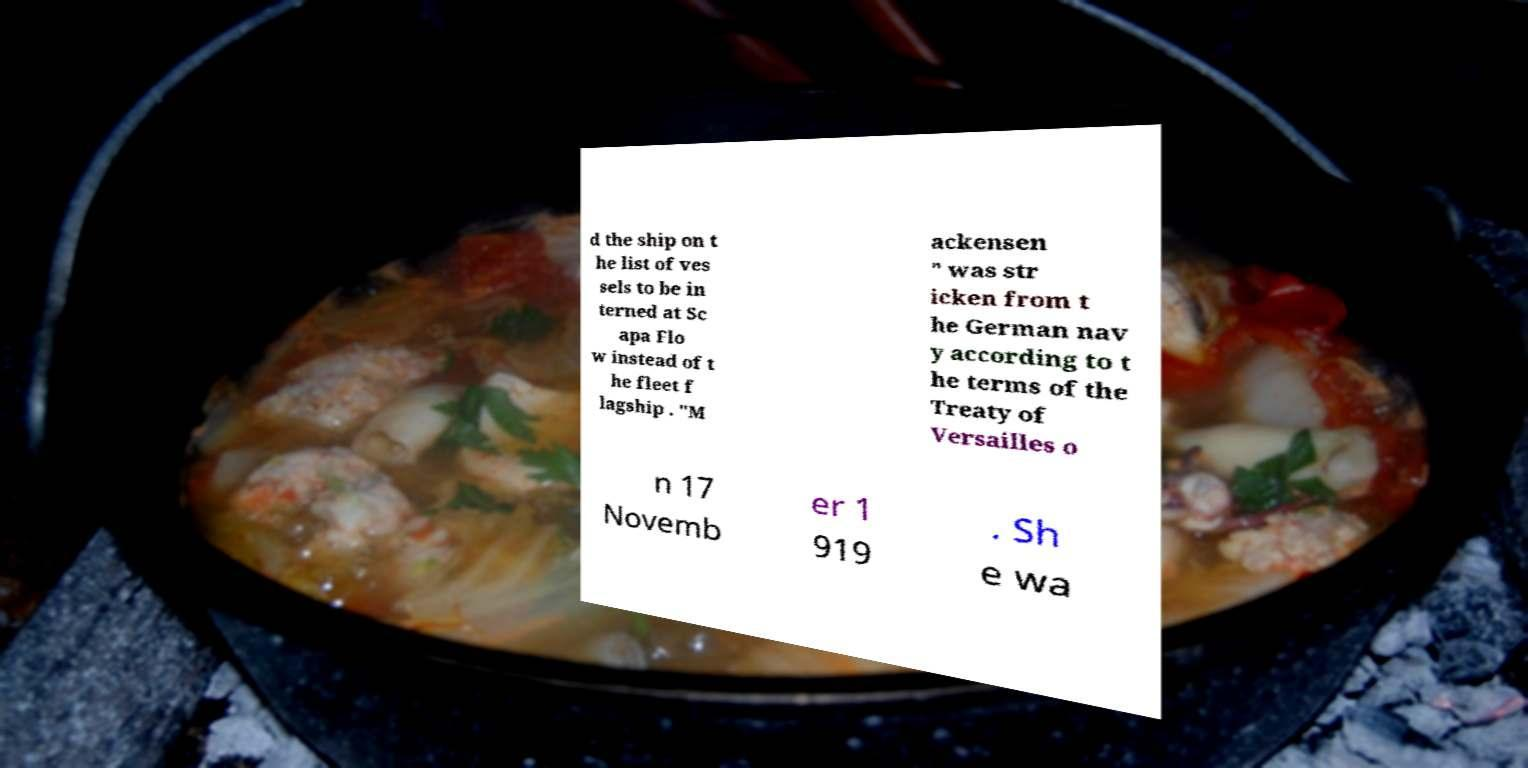Please read and relay the text visible in this image. What does it say? d the ship on t he list of ves sels to be in terned at Sc apa Flo w instead of t he fleet f lagship . "M ackensen " was str icken from t he German nav y according to t he terms of the Treaty of Versailles o n 17 Novemb er 1 919 . Sh e wa 